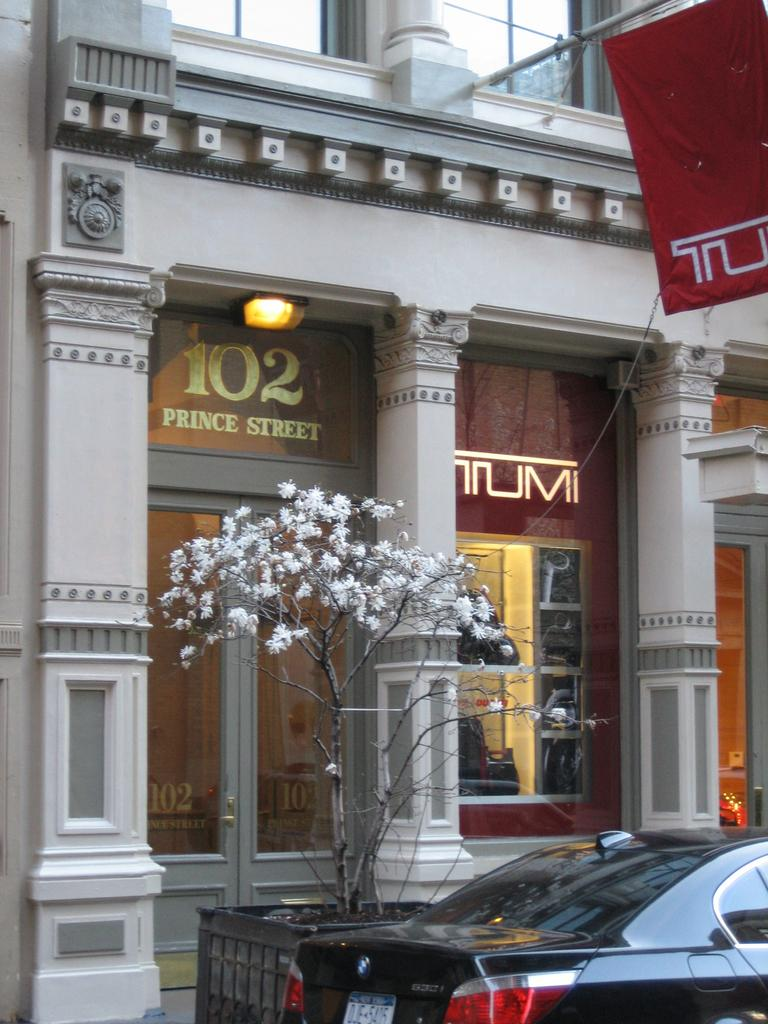What type of structure is visible in the image? There is a building with windows in the image. What can be seen illuminated in the image? There are lights visible in the image. What symbol or emblem is present in the image? There is a flag in the image. What type of plant life is present in the image? There is a tree in the image. What type of surface is present in the image? Soil is present in the image. What type of container is visible in the image? There is a black color pot in the image. What type of vehicle is present at the bottom of the image? There is a car at the bottom of the image. How many slaves are visible in the image? There are no slaves present in the image. What is the rate of the car's speed in the image? The image does not provide information about the car's speed, so it cannot be determined. 